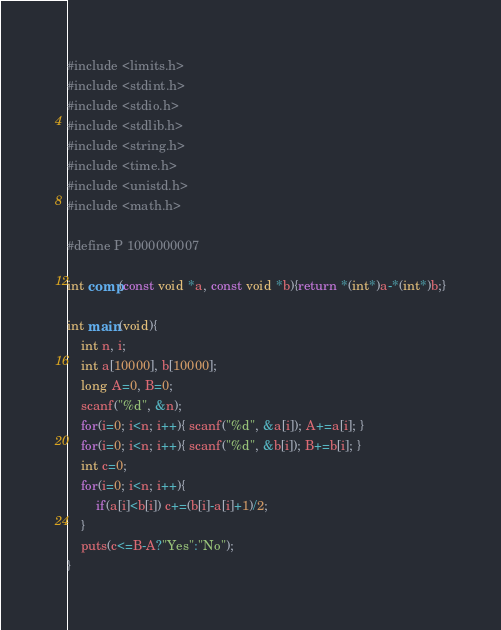Convert code to text. <code><loc_0><loc_0><loc_500><loc_500><_C_>#include <limits.h>
#include <stdint.h>
#include <stdio.h>
#include <stdlib.h>
#include <string.h>
#include <time.h>
#include <unistd.h>
#include <math.h>

#define P 1000000007

int comp(const void *a, const void *b){return *(int*)a-*(int*)b;}

int main(void){
	int n, i;
	int a[10000], b[10000];
	long A=0, B=0;
	scanf("%d", &n);
	for(i=0; i<n; i++){ scanf("%d", &a[i]); A+=a[i]; }
	for(i=0; i<n; i++){ scanf("%d", &b[i]); B+=b[i]; }
	int c=0;
	for(i=0; i<n; i++){
		if(a[i]<b[i]) c+=(b[i]-a[i]+1)/2;
	}
	puts(c<=B-A?"Yes":"No");
}
</code> 